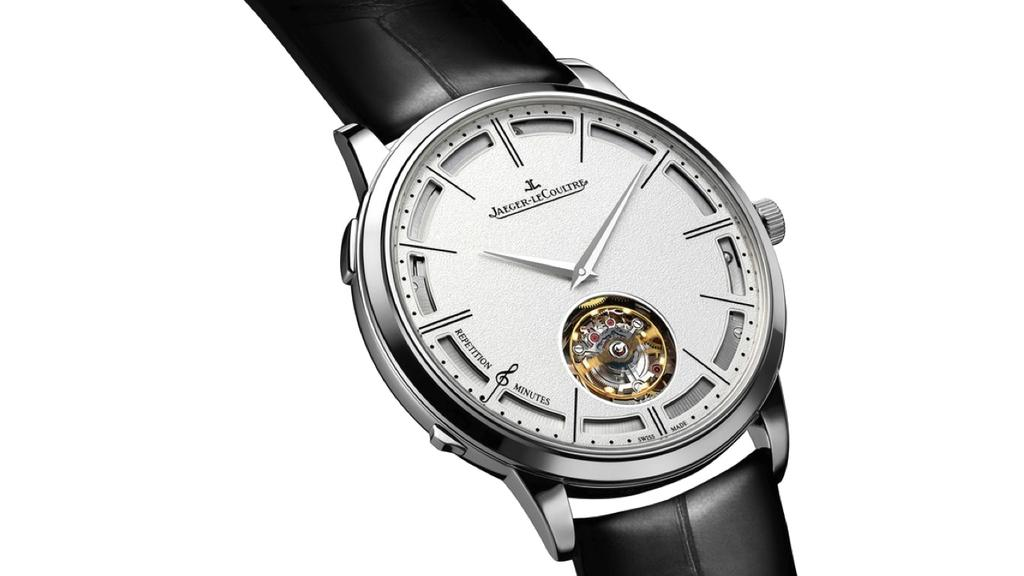<image>
Relay a brief, clear account of the picture shown. the word coultre that is on a watch 